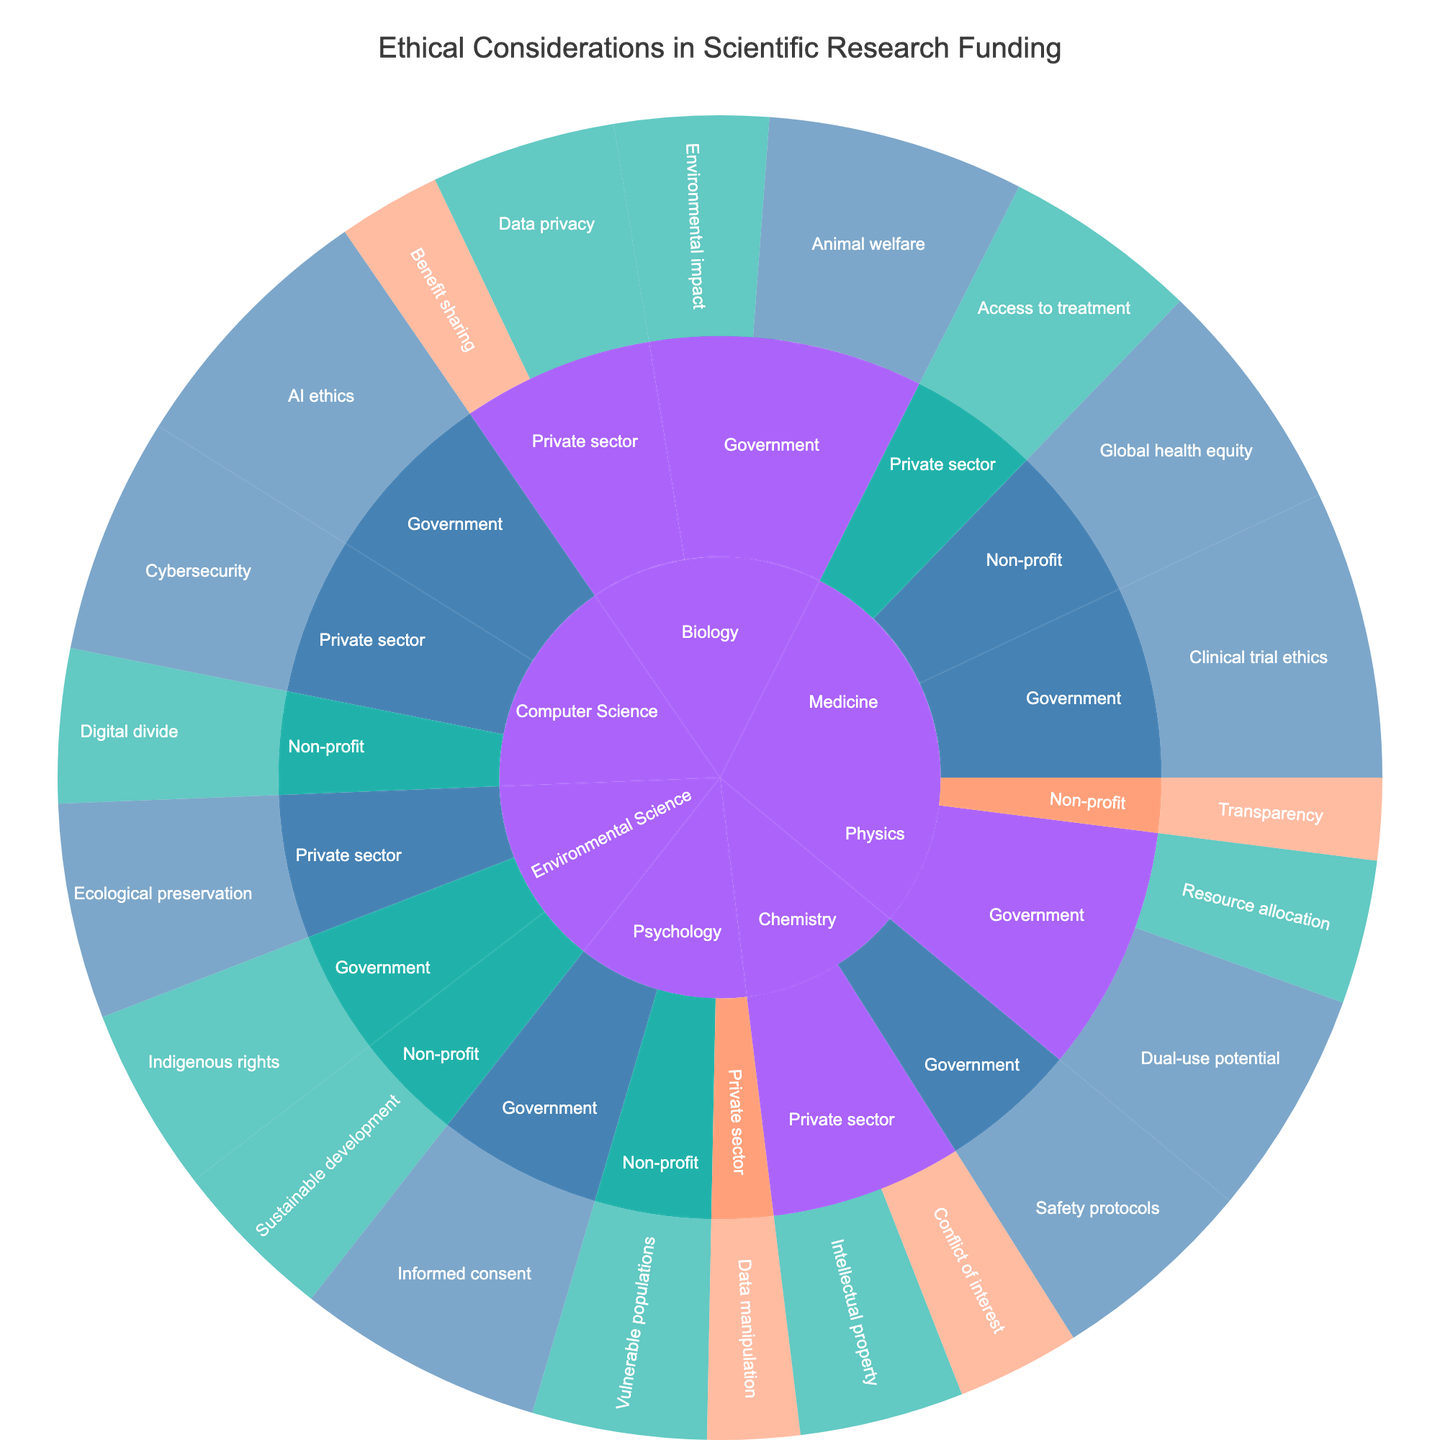How many fields are represented in the plot? To answer this, look at the outermost ring of the sunburst plot, which represents different fields. Count the unique sections.
Answer: Six Which field has the highest value for a single ethical consideration? Identify the segment with the largest value in the plot. Look for the field associated with that section.
Answer: Medicine What is the total value for ethical considerations funded by the private sector? Sum the values of all segments funded by the private sector across all fields. Values: 10 (Biology) + 18 (Data privacy) + 16 (Chemistry) + 12 (Chemistry) + 9 (Psychology) + 19 (Medicine) + 21 (Environmental Science) + 23 (Computer Science) = 128
Answer: 128 Which funding source has the highest cumulative impact in Biology? Compare the total values of ethical considerations for each funding source within Biology. Government: 25 + 15 = 40; Private sector: 18 + 10 = 28. The Government has the highest value.
Answer: Government What is the average value of 'Medium' impact ethical considerations within Physics? First, identify the 'Medium' impact segments within Physics, then sum their values and divide by their count. Resource allocation: 14. Since there's only one segment, the average value is 14.
Answer: 14 Which ethical consideration in the Government funding source has a 'Low' impact? Scan the sections under Government funding and identify any with a 'Low' impact. There are none with 'Low' impact.
Answer: None Compare the impact values of Data privacy and AI ethics in Computer Science. Which one is higher? Examine the segments for Data privacy and AI ethics within Computer Science. Data privacy: 18, AI ethics: 26. The impact value for AI ethics is higher.
Answer: AI ethics In which field does the Non-profit sector fund the highest value ethical consideration? Check the highest value segments under Non-profit for each field. Psychology (17), Medicine (23), Environmental Science (16), Computer Science (15). Medicine has the highest value.
Answer: Medicine What is the lowest value ethical consideration in Psychology, and what is its impact? Identify the segment with the lowest value within Psychology, which is Data manipulation with a value of 9 and a 'Low' impact.
Answer: Data manipulation, Low What is the sum of 'High' impact ethical considerations across all fields? Sum the values of all 'High' impact segments in the plot. Values: 25 (Biology) + 22 (Physics) + 20 (Chemistry) + 24 (Psychology) + 28 (Medicine) + 23 (Global health equity) + 21 (Environmental Science) + 26 (Computer Science) + 23 (Cybersecurity) = 212
Answer: 212 